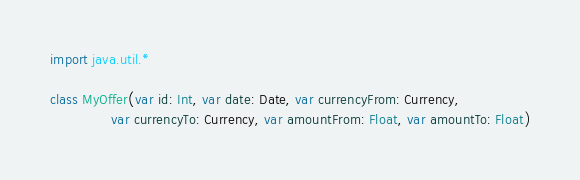Convert code to text. <code><loc_0><loc_0><loc_500><loc_500><_Kotlin_>
import java.util.*

class MyOffer(var id: Int, var date: Date, var currencyFrom: Currency,
              var currencyTo: Currency, var amountFrom: Float, var amountTo: Float)</code> 